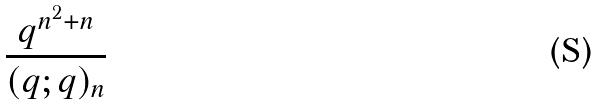<formula> <loc_0><loc_0><loc_500><loc_500>\frac { q ^ { n ^ { 2 } + n } } { ( q ; q ) _ { n } }</formula> 